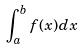<formula> <loc_0><loc_0><loc_500><loc_500>\int _ { a } ^ { b } f ( x ) d x</formula> 